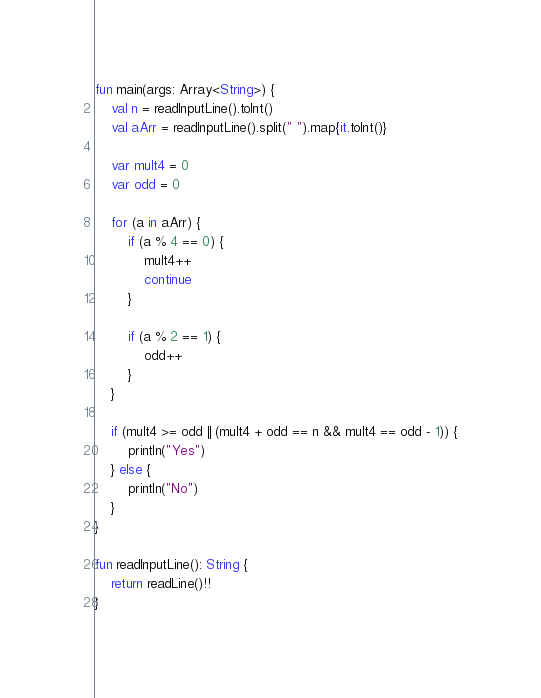Convert code to text. <code><loc_0><loc_0><loc_500><loc_500><_Kotlin_>fun main(args: Array<String>) {
    val n = readInputLine().toInt()
    val aArr = readInputLine().split(" ").map{it.toInt()}
    
    var mult4 = 0
    var odd = 0
    
    for (a in aArr) {
        if (a % 4 == 0) {
            mult4++
            continue
        }
        
        if (a % 2 == 1) {
            odd++
        }
    }
    
    if (mult4 >= odd || (mult4 + odd == n && mult4 == odd - 1)) {
        println("Yes")
    } else {
        println("No")
    }
}

fun readInputLine(): String {
    return readLine()!!
}
</code> 